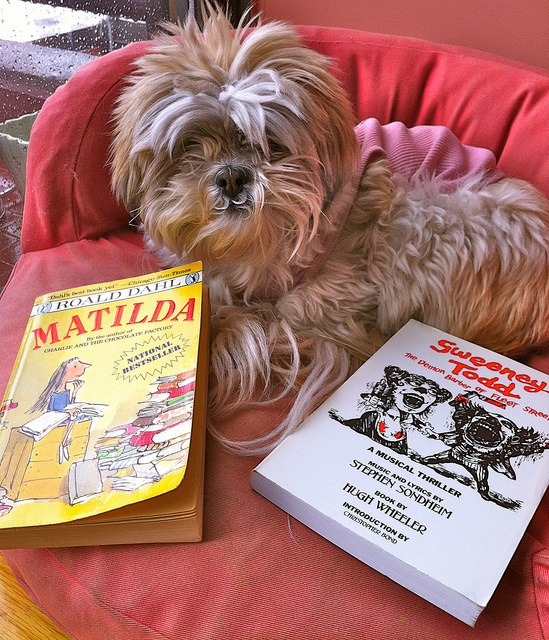Describe the objects in this image and their specific colors. I can see dog in white, brown, maroon, and darkgray tones, chair in white, salmon, brown, and maroon tones, couch in white, salmon, brown, and maroon tones, book in white, lavender, black, and darkgray tones, and book in white, khaki, ivory, and brown tones in this image. 